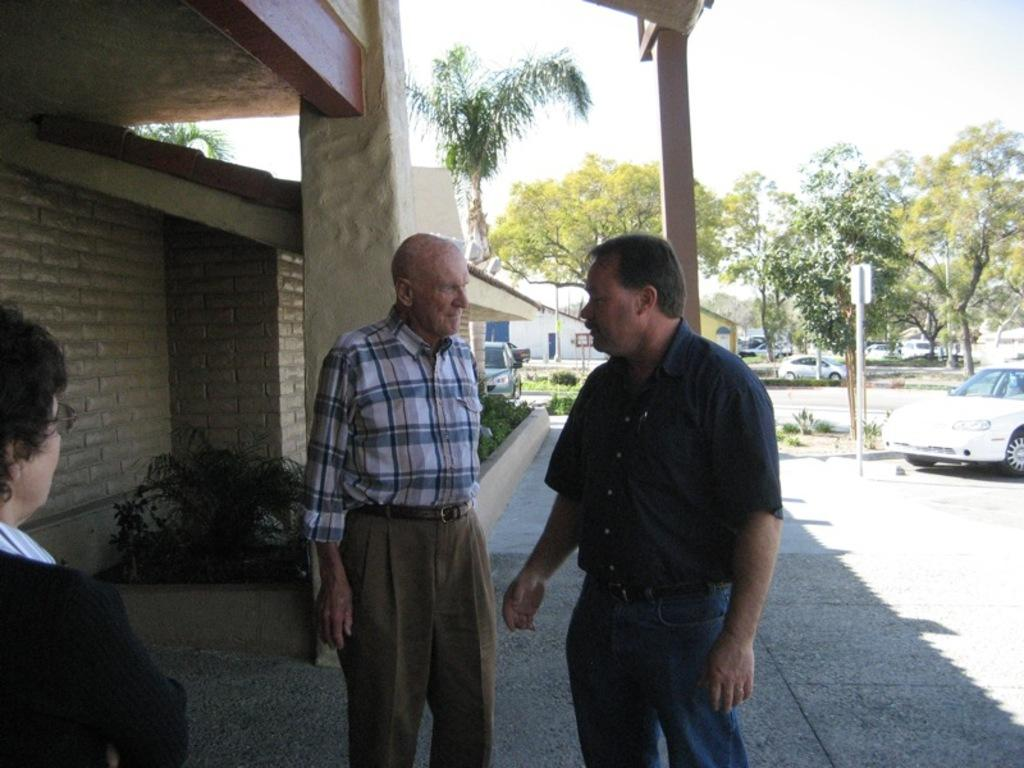How many people are present in the image? There are three people standing in the image. What else can be seen in the image besides the people? There are plants, a board on a pole, and a wall visible in the image. What can be seen in the background of the image? Vehicles, trees, and the sky are visible in the background of the image. What type of fish can be seen swimming in the drawer in the image? There is no drawer or fish present in the image. 